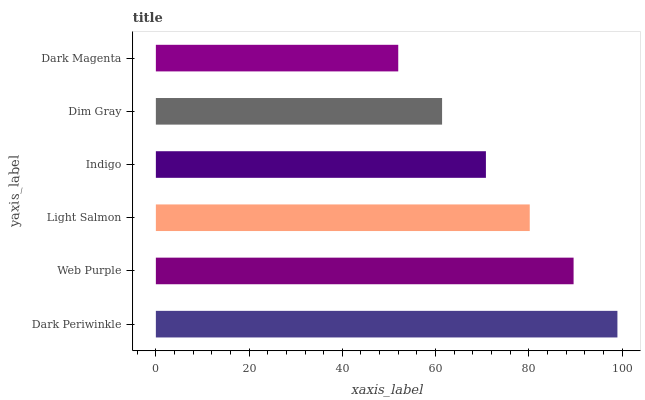Is Dark Magenta the minimum?
Answer yes or no. Yes. Is Dark Periwinkle the maximum?
Answer yes or no. Yes. Is Web Purple the minimum?
Answer yes or no. No. Is Web Purple the maximum?
Answer yes or no. No. Is Dark Periwinkle greater than Web Purple?
Answer yes or no. Yes. Is Web Purple less than Dark Periwinkle?
Answer yes or no. Yes. Is Web Purple greater than Dark Periwinkle?
Answer yes or no. No. Is Dark Periwinkle less than Web Purple?
Answer yes or no. No. Is Light Salmon the high median?
Answer yes or no. Yes. Is Indigo the low median?
Answer yes or no. Yes. Is Indigo the high median?
Answer yes or no. No. Is Dim Gray the low median?
Answer yes or no. No. 